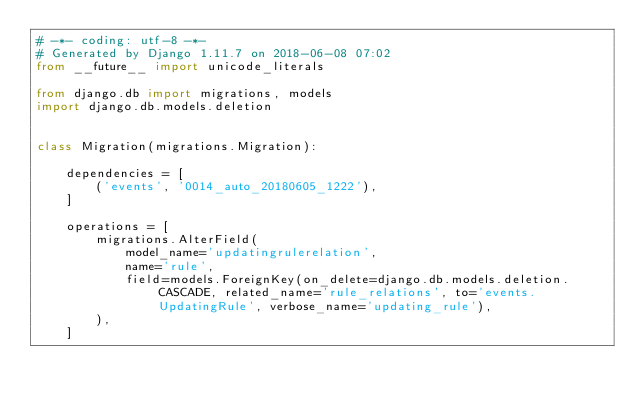Convert code to text. <code><loc_0><loc_0><loc_500><loc_500><_Python_># -*- coding: utf-8 -*-
# Generated by Django 1.11.7 on 2018-06-08 07:02
from __future__ import unicode_literals

from django.db import migrations, models
import django.db.models.deletion


class Migration(migrations.Migration):

    dependencies = [
        ('events', '0014_auto_20180605_1222'),
    ]

    operations = [
        migrations.AlterField(
            model_name='updatingrulerelation',
            name='rule',
            field=models.ForeignKey(on_delete=django.db.models.deletion.CASCADE, related_name='rule_relations', to='events.UpdatingRule', verbose_name='updating_rule'),
        ),
    ]
</code> 